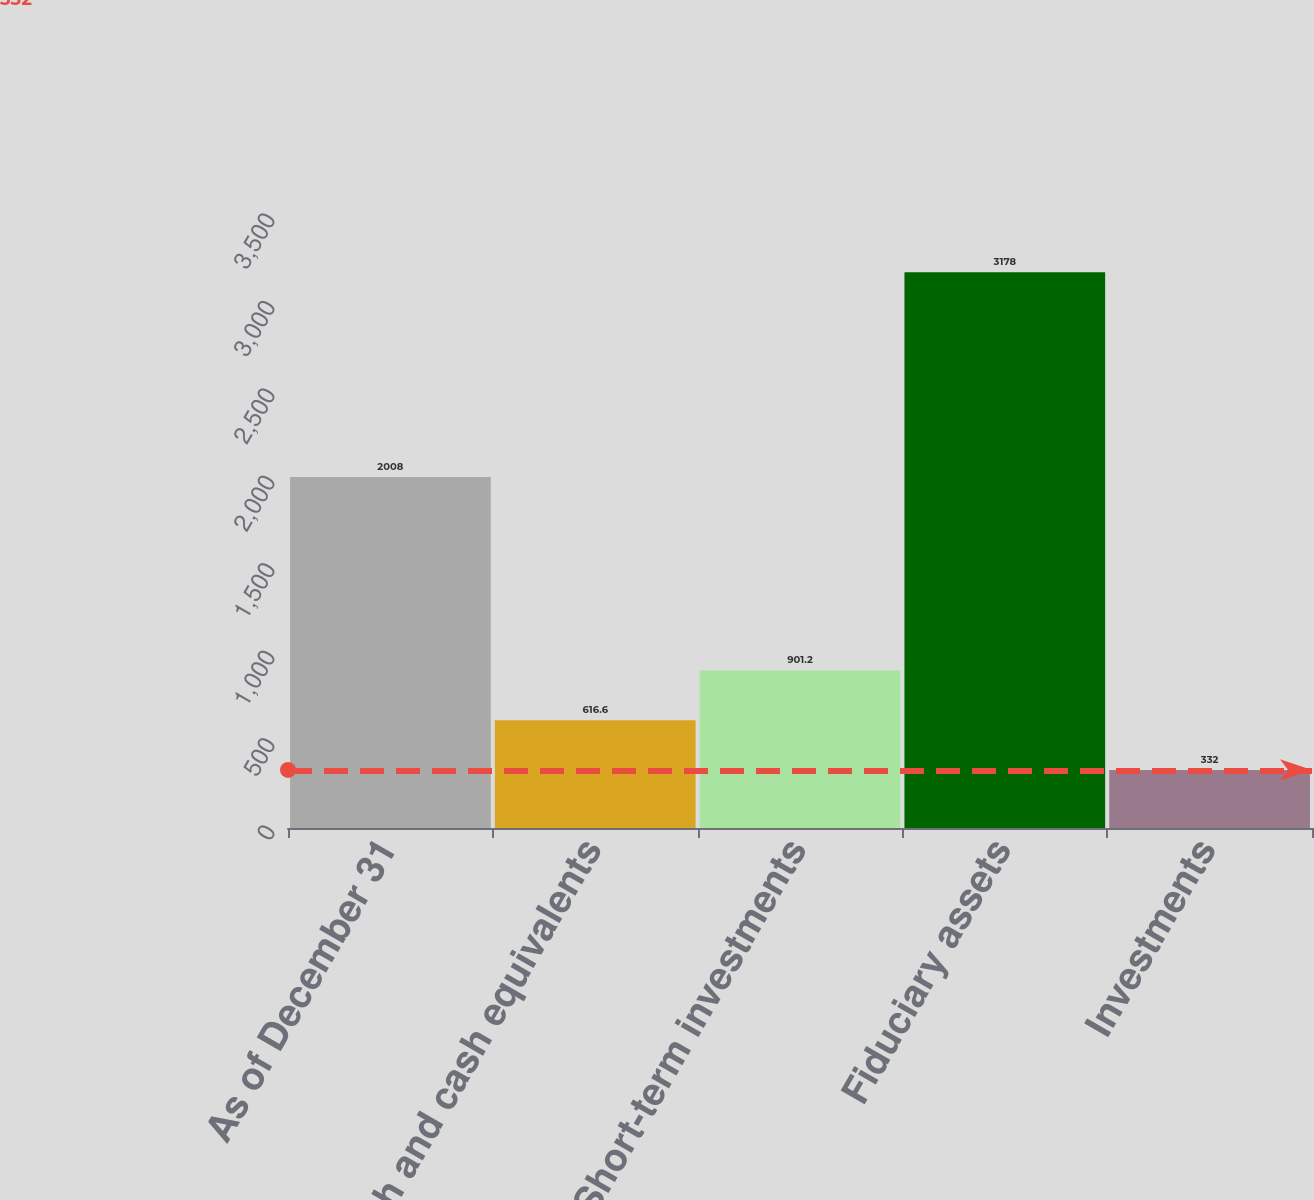Convert chart to OTSL. <chart><loc_0><loc_0><loc_500><loc_500><bar_chart><fcel>As of December 31<fcel>Cash and cash equivalents<fcel>Short-term investments<fcel>Fiduciary assets<fcel>Investments<nl><fcel>2008<fcel>616.6<fcel>901.2<fcel>3178<fcel>332<nl></chart> 